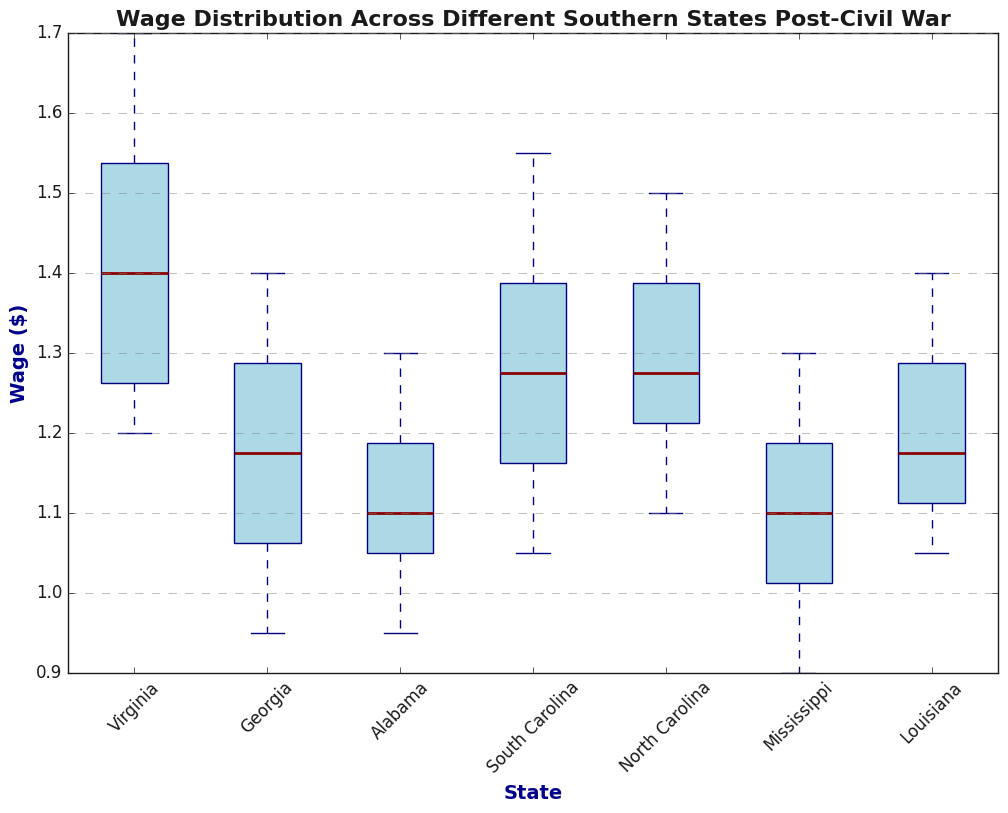What's the median wage for Virginia? The median wage is the middle value when the data points are ordered from lowest to highest. In the box plot for Virginia, the median is marked by the dark red line inside the box.
Answer: 1.45 Which state has the highest median wage? The state with the highest median wage is the one with the highest position of the dark red line inside the box. By visual inspection, Virginia has the highest median wage.
Answer: Virginia Compare the interquartile ranges (IQR) of Georgia and Alabama. Which state has a wider IQR? IQR is the range within the box represented by the height between the bottom (Q1) and the top (Q3) of the box. By visual inspection, Georgia's box is taller than Alabama's, indicating a wider IQR.
Answer: Georgia What is the range of wages in South Carolina? The range is the difference between the highest and lowest wage values represented by the whiskers. The whisker extends from 1.05 to 1.55 in South Carolina. So, the range is 1.55 - 1.05.
Answer: 0.50 Are there any outliers in Mississippi's wage distribution? Outliers are typically represented by individual points outside the whiskers of the box plot. By visual inspection, Mississippi has no individual points outside the whiskers.
Answer: No Which states have a median wage higher than 1.25? The states with a median wage higher than 1.25 have their median line above the 1.25 mark. By visual inspection, these states are Virginia, South Carolina, North Carolina, and Louisiana.
Answer: Virginia, South Carolina, North Carolina, Louisiana Compare the highest wage value among all states. Which state has the highest maximum wage? The highest wage value is represented by the top-most point of the whisker. By visual inspection, Virginia has the highest maximum wage, which is at 1.70.
Answer: Virginia What is the difference between the median wages of North Carolina and Mississippi? Subtract the median wage of Mississippi from the median wage of North Carolina. North Carolina's median is at approximately 1.25 and Mississippi's is at approximately 1.10. So, the difference is 1.25 - 1.10.
Answer: 0.15 Which state's wage distribution appears to be the most symmetrical? A symmetrical distribution will have the median line roughly in the middle of the box, and the whiskers will be of approximately equal length. By visual inspection, Alabama's distribution appears to be the most symmetrical.
Answer: Alabama 